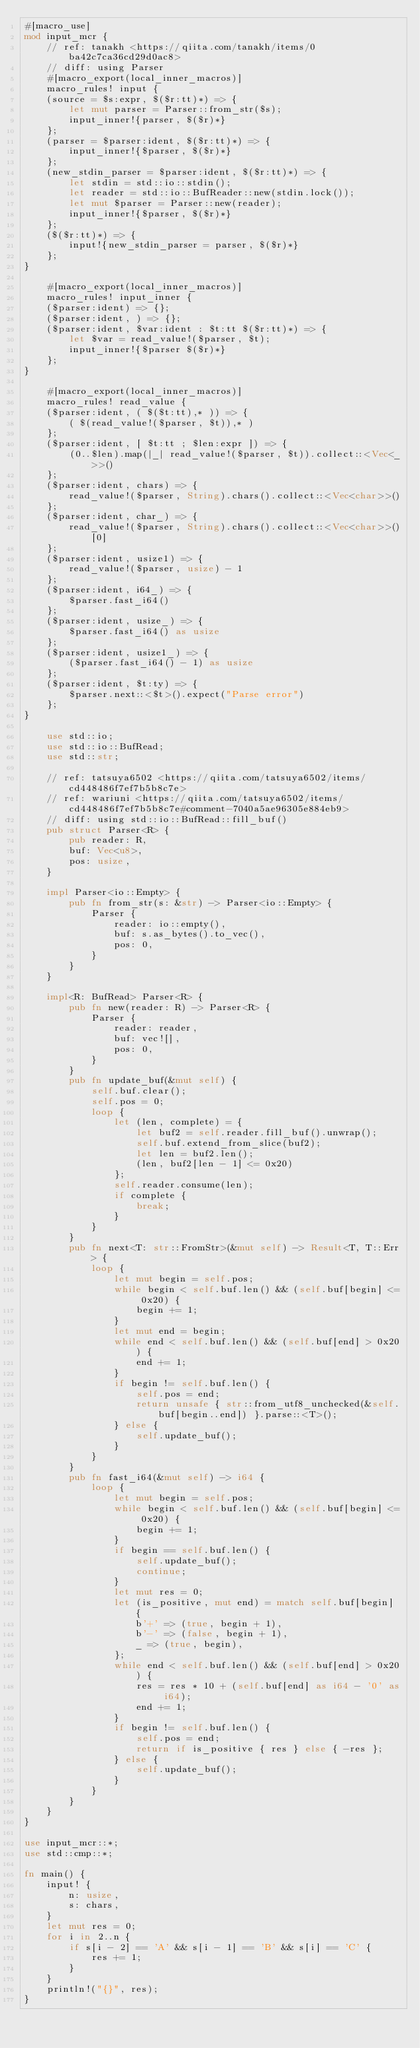<code> <loc_0><loc_0><loc_500><loc_500><_Rust_>#[macro_use]
mod input_mcr {
    // ref: tanakh <https://qiita.com/tanakh/items/0ba42c7ca36cd29d0ac8>
    // diff: using Parser
    #[macro_export(local_inner_macros)]
    macro_rules! input {
    (source = $s:expr, $($r:tt)*) => {
        let mut parser = Parser::from_str($s);
        input_inner!{parser, $($r)*}
    };
    (parser = $parser:ident, $($r:tt)*) => {
        input_inner!{$parser, $($r)*}
    };
    (new_stdin_parser = $parser:ident, $($r:tt)*) => {
        let stdin = std::io::stdin();
        let reader = std::io::BufReader::new(stdin.lock());
        let mut $parser = Parser::new(reader);
        input_inner!{$parser, $($r)*}
    };
    ($($r:tt)*) => {
        input!{new_stdin_parser = parser, $($r)*}
    };
}

    #[macro_export(local_inner_macros)]
    macro_rules! input_inner {
    ($parser:ident) => {};
    ($parser:ident, ) => {};
    ($parser:ident, $var:ident : $t:tt $($r:tt)*) => {
        let $var = read_value!($parser, $t);
        input_inner!{$parser $($r)*}
    };
}

    #[macro_export(local_inner_macros)]
    macro_rules! read_value {
    ($parser:ident, ( $($t:tt),* )) => {
        ( $(read_value!($parser, $t)),* )
    };
    ($parser:ident, [ $t:tt ; $len:expr ]) => {
        (0..$len).map(|_| read_value!($parser, $t)).collect::<Vec<_>>()
    };
    ($parser:ident, chars) => {
        read_value!($parser, String).chars().collect::<Vec<char>>()
    };
    ($parser:ident, char_) => {
        read_value!($parser, String).chars().collect::<Vec<char>>()[0]
    };
    ($parser:ident, usize1) => {
        read_value!($parser, usize) - 1
    };
    ($parser:ident, i64_) => {
        $parser.fast_i64()
    };
    ($parser:ident, usize_) => {
        $parser.fast_i64() as usize
    };
    ($parser:ident, usize1_) => {
        ($parser.fast_i64() - 1) as usize
    };
    ($parser:ident, $t:ty) => {
        $parser.next::<$t>().expect("Parse error")
    };
}

    use std::io;
    use std::io::BufRead;
    use std::str;

    // ref: tatsuya6502 <https://qiita.com/tatsuya6502/items/cd448486f7ef7b5b8c7e>
    // ref: wariuni <https://qiita.com/tatsuya6502/items/cd448486f7ef7b5b8c7e#comment-7040a5ae96305e884eb9>
    // diff: using std::io::BufRead::fill_buf()
    pub struct Parser<R> {
        pub reader: R,
        buf: Vec<u8>,
        pos: usize,
    }

    impl Parser<io::Empty> {
        pub fn from_str(s: &str) -> Parser<io::Empty> {
            Parser {
                reader: io::empty(),
                buf: s.as_bytes().to_vec(),
                pos: 0,
            }
        }
    }

    impl<R: BufRead> Parser<R> {
        pub fn new(reader: R) -> Parser<R> {
            Parser {
                reader: reader,
                buf: vec![],
                pos: 0,
            }
        }
        pub fn update_buf(&mut self) {
            self.buf.clear();
            self.pos = 0;
            loop {
                let (len, complete) = {
                    let buf2 = self.reader.fill_buf().unwrap();
                    self.buf.extend_from_slice(buf2);
                    let len = buf2.len();
                    (len, buf2[len - 1] <= 0x20)
                };
                self.reader.consume(len);
                if complete {
                    break;
                }
            }
        }
        pub fn next<T: str::FromStr>(&mut self) -> Result<T, T::Err> {
            loop {
                let mut begin = self.pos;
                while begin < self.buf.len() && (self.buf[begin] <= 0x20) {
                    begin += 1;
                }
                let mut end = begin;
                while end < self.buf.len() && (self.buf[end] > 0x20) {
                    end += 1;
                }
                if begin != self.buf.len() {
                    self.pos = end;
                    return unsafe { str::from_utf8_unchecked(&self.buf[begin..end]) }.parse::<T>();
                } else {
                    self.update_buf();
                }
            }
        }
        pub fn fast_i64(&mut self) -> i64 {
            loop {
                let mut begin = self.pos;
                while begin < self.buf.len() && (self.buf[begin] <= 0x20) {
                    begin += 1;
                }
                if begin == self.buf.len() {
                    self.update_buf();
                    continue;
                }
                let mut res = 0;
                let (is_positive, mut end) = match self.buf[begin] {
                    b'+' => (true, begin + 1),
                    b'-' => (false, begin + 1),
                    _ => (true, begin),
                };
                while end < self.buf.len() && (self.buf[end] > 0x20) {
                    res = res * 10 + (self.buf[end] as i64 - '0' as i64);
                    end += 1;
                }
                if begin != self.buf.len() {
                    self.pos = end;
                    return if is_positive { res } else { -res };
                } else {
                    self.update_buf();
                }
            }
        }
    }
}

use input_mcr::*;
use std::cmp::*;

fn main() {
    input! {
        n: usize,
        s: chars,
    }
    let mut res = 0;
    for i in 2..n {
        if s[i - 2] == 'A' && s[i - 1] == 'B' && s[i] == 'C' {
            res += 1;
        }
    }
    println!("{}", res);
}

</code> 